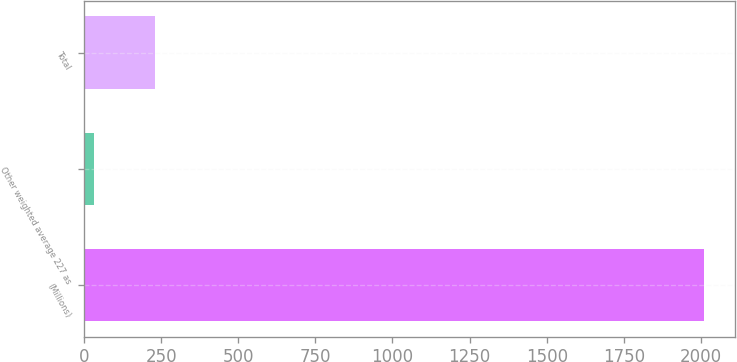Convert chart. <chart><loc_0><loc_0><loc_500><loc_500><bar_chart><fcel>(Millions)<fcel>Other weighted average 227 as<fcel>Total<nl><fcel>2011<fcel>33<fcel>230.8<nl></chart> 